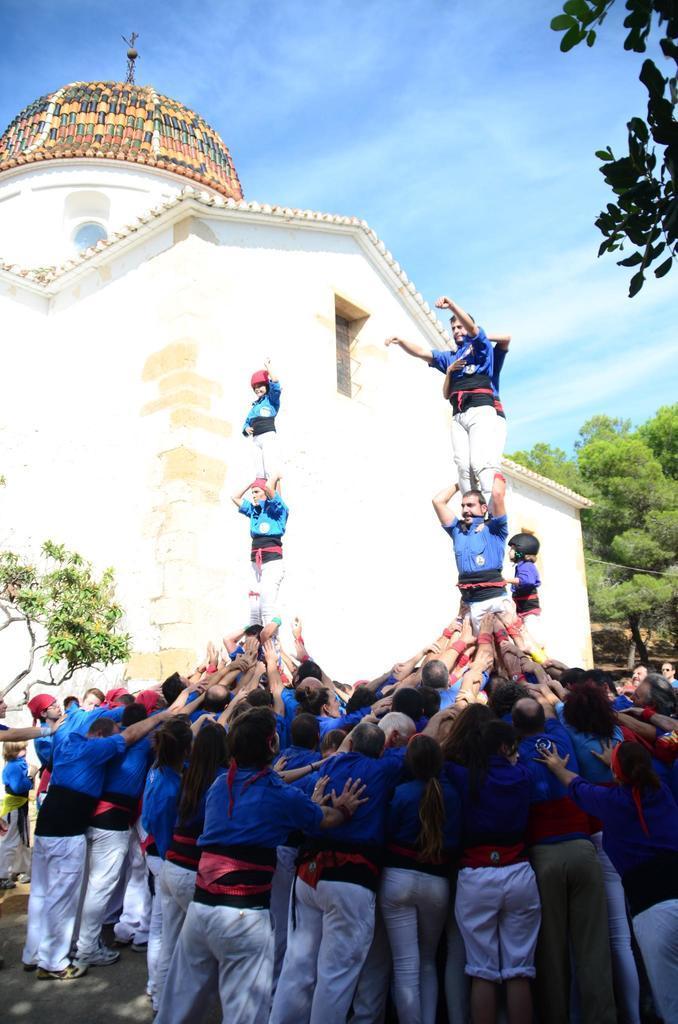Can you describe this image briefly? In this picture, there are group of people forming into pyramids. All the people in the picture are wearing blue t shirts and white trousers. In the background, there is a castle, trees and a sky. 